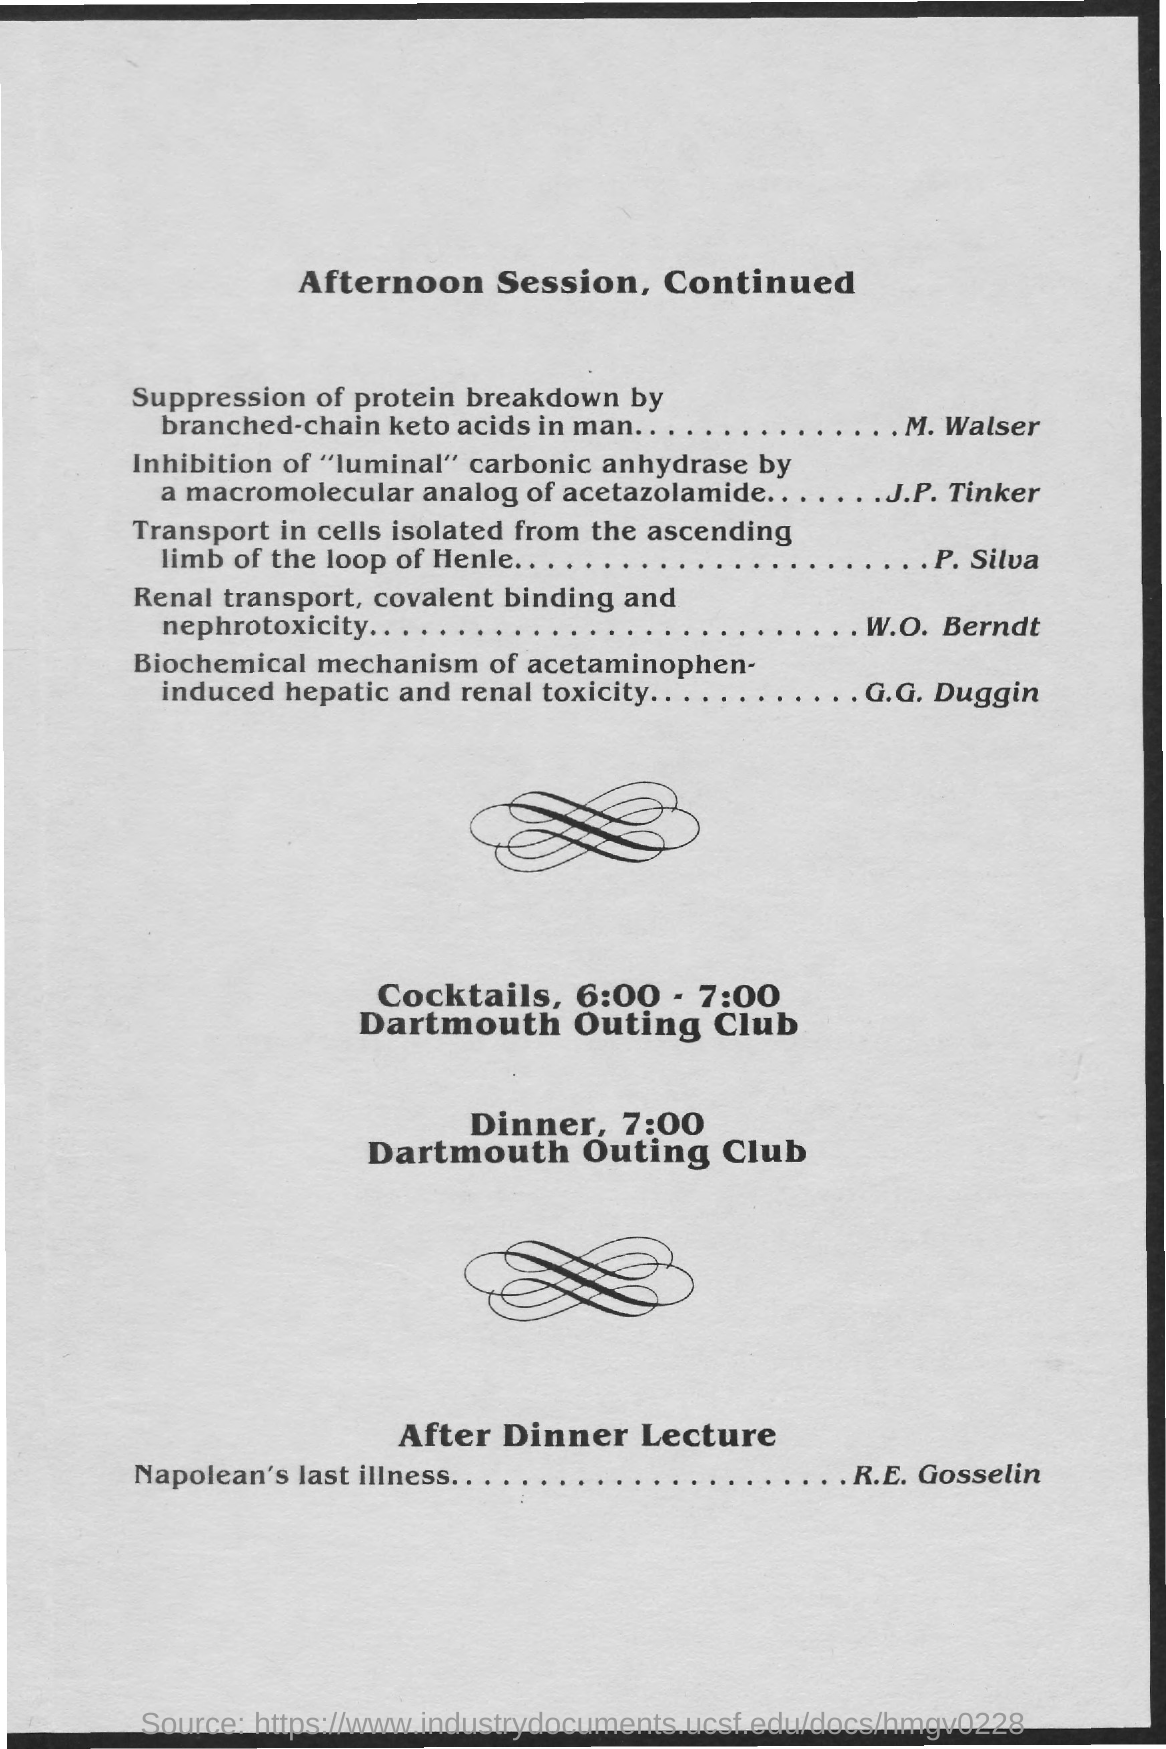What is the time mentioned for dinner ?
Ensure brevity in your answer.  7:00. What  is the venue for dinner ?
Keep it short and to the point. Dartmouth Outing Club. What is the after dinner lecture?
Your answer should be very brief. Napolean's last illness.....R.E. Gosselin. 